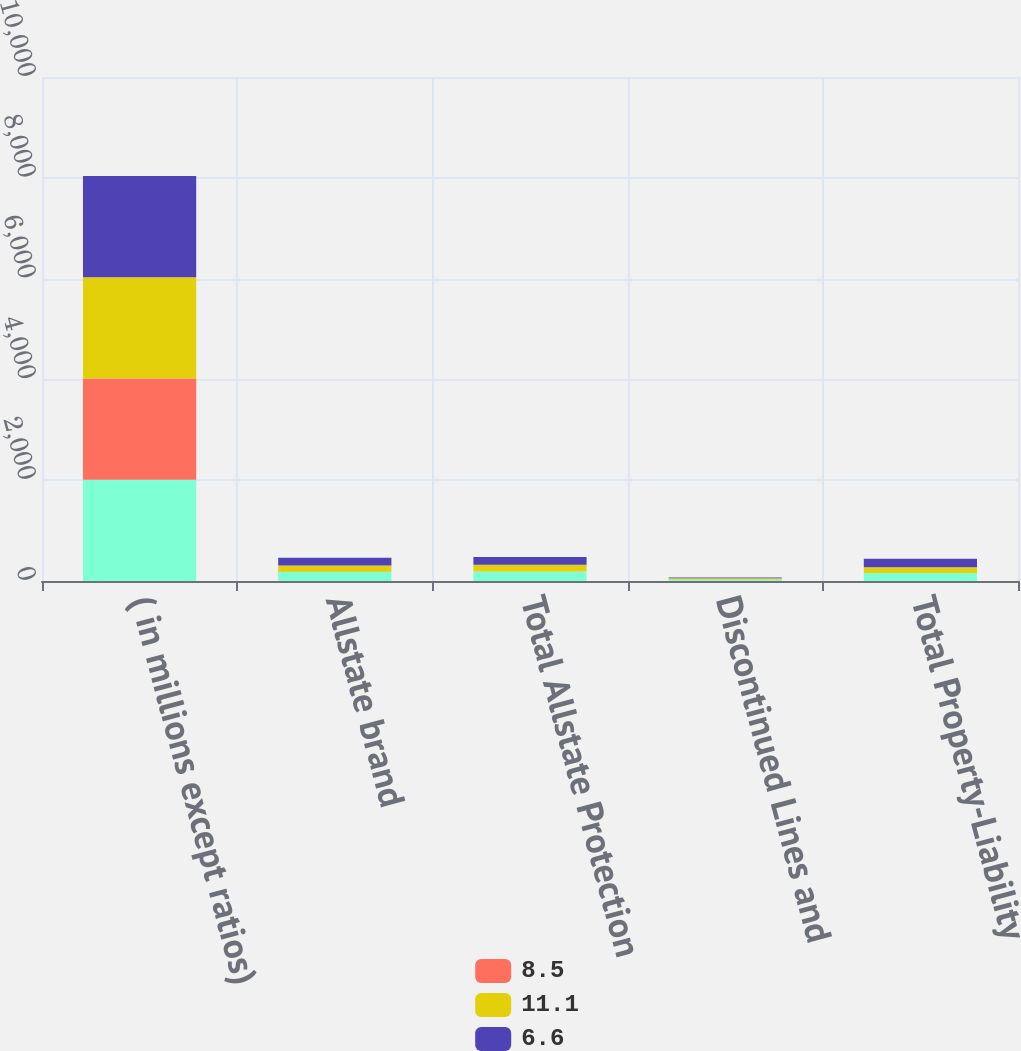Convert chart to OTSL. <chart><loc_0><loc_0><loc_500><loc_500><stacked_bar_chart><ecel><fcel>( in millions except ratios)<fcel>Allstate brand<fcel>Total Allstate Protection<fcel>Discontinued Lines and<fcel>Total Property-Liability<nl><fcel>nan<fcel>2010<fcel>181<fcel>187<fcel>28<fcel>159<nl><fcel>8.5<fcel>2010<fcel>0.7<fcel>0.7<fcel>0.1<fcel>0.6<nl><fcel>11.1<fcel>2009<fcel>126<fcel>136<fcel>24<fcel>112<nl><fcel>6.6<fcel>2008<fcel>155<fcel>152<fcel>18<fcel>170<nl></chart> 